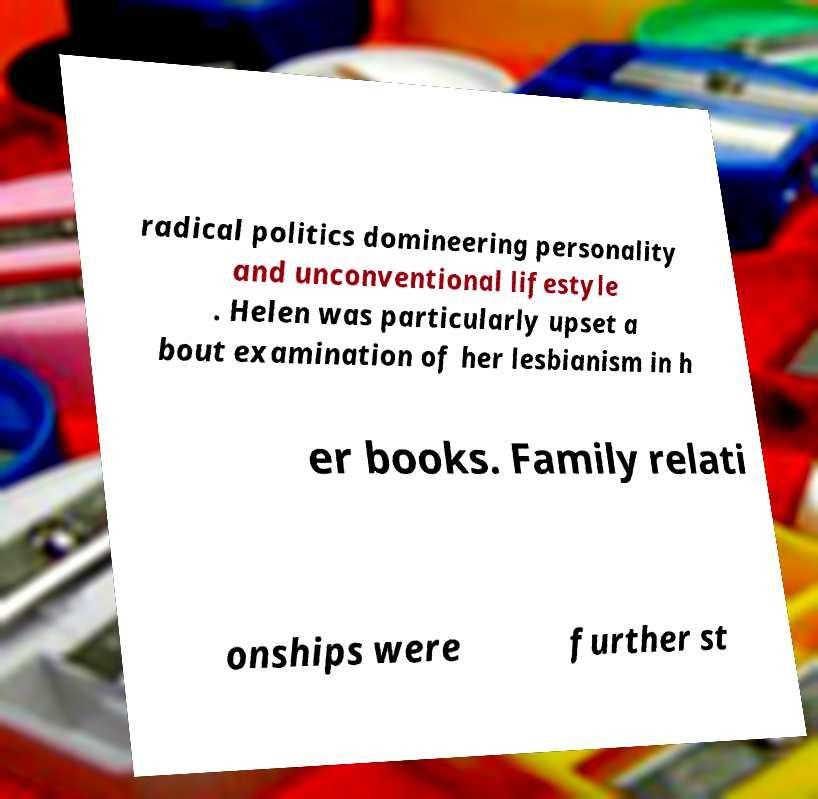What messages or text are displayed in this image? I need them in a readable, typed format. radical politics domineering personality and unconventional lifestyle . Helen was particularly upset a bout examination of her lesbianism in h er books. Family relati onships were further st 